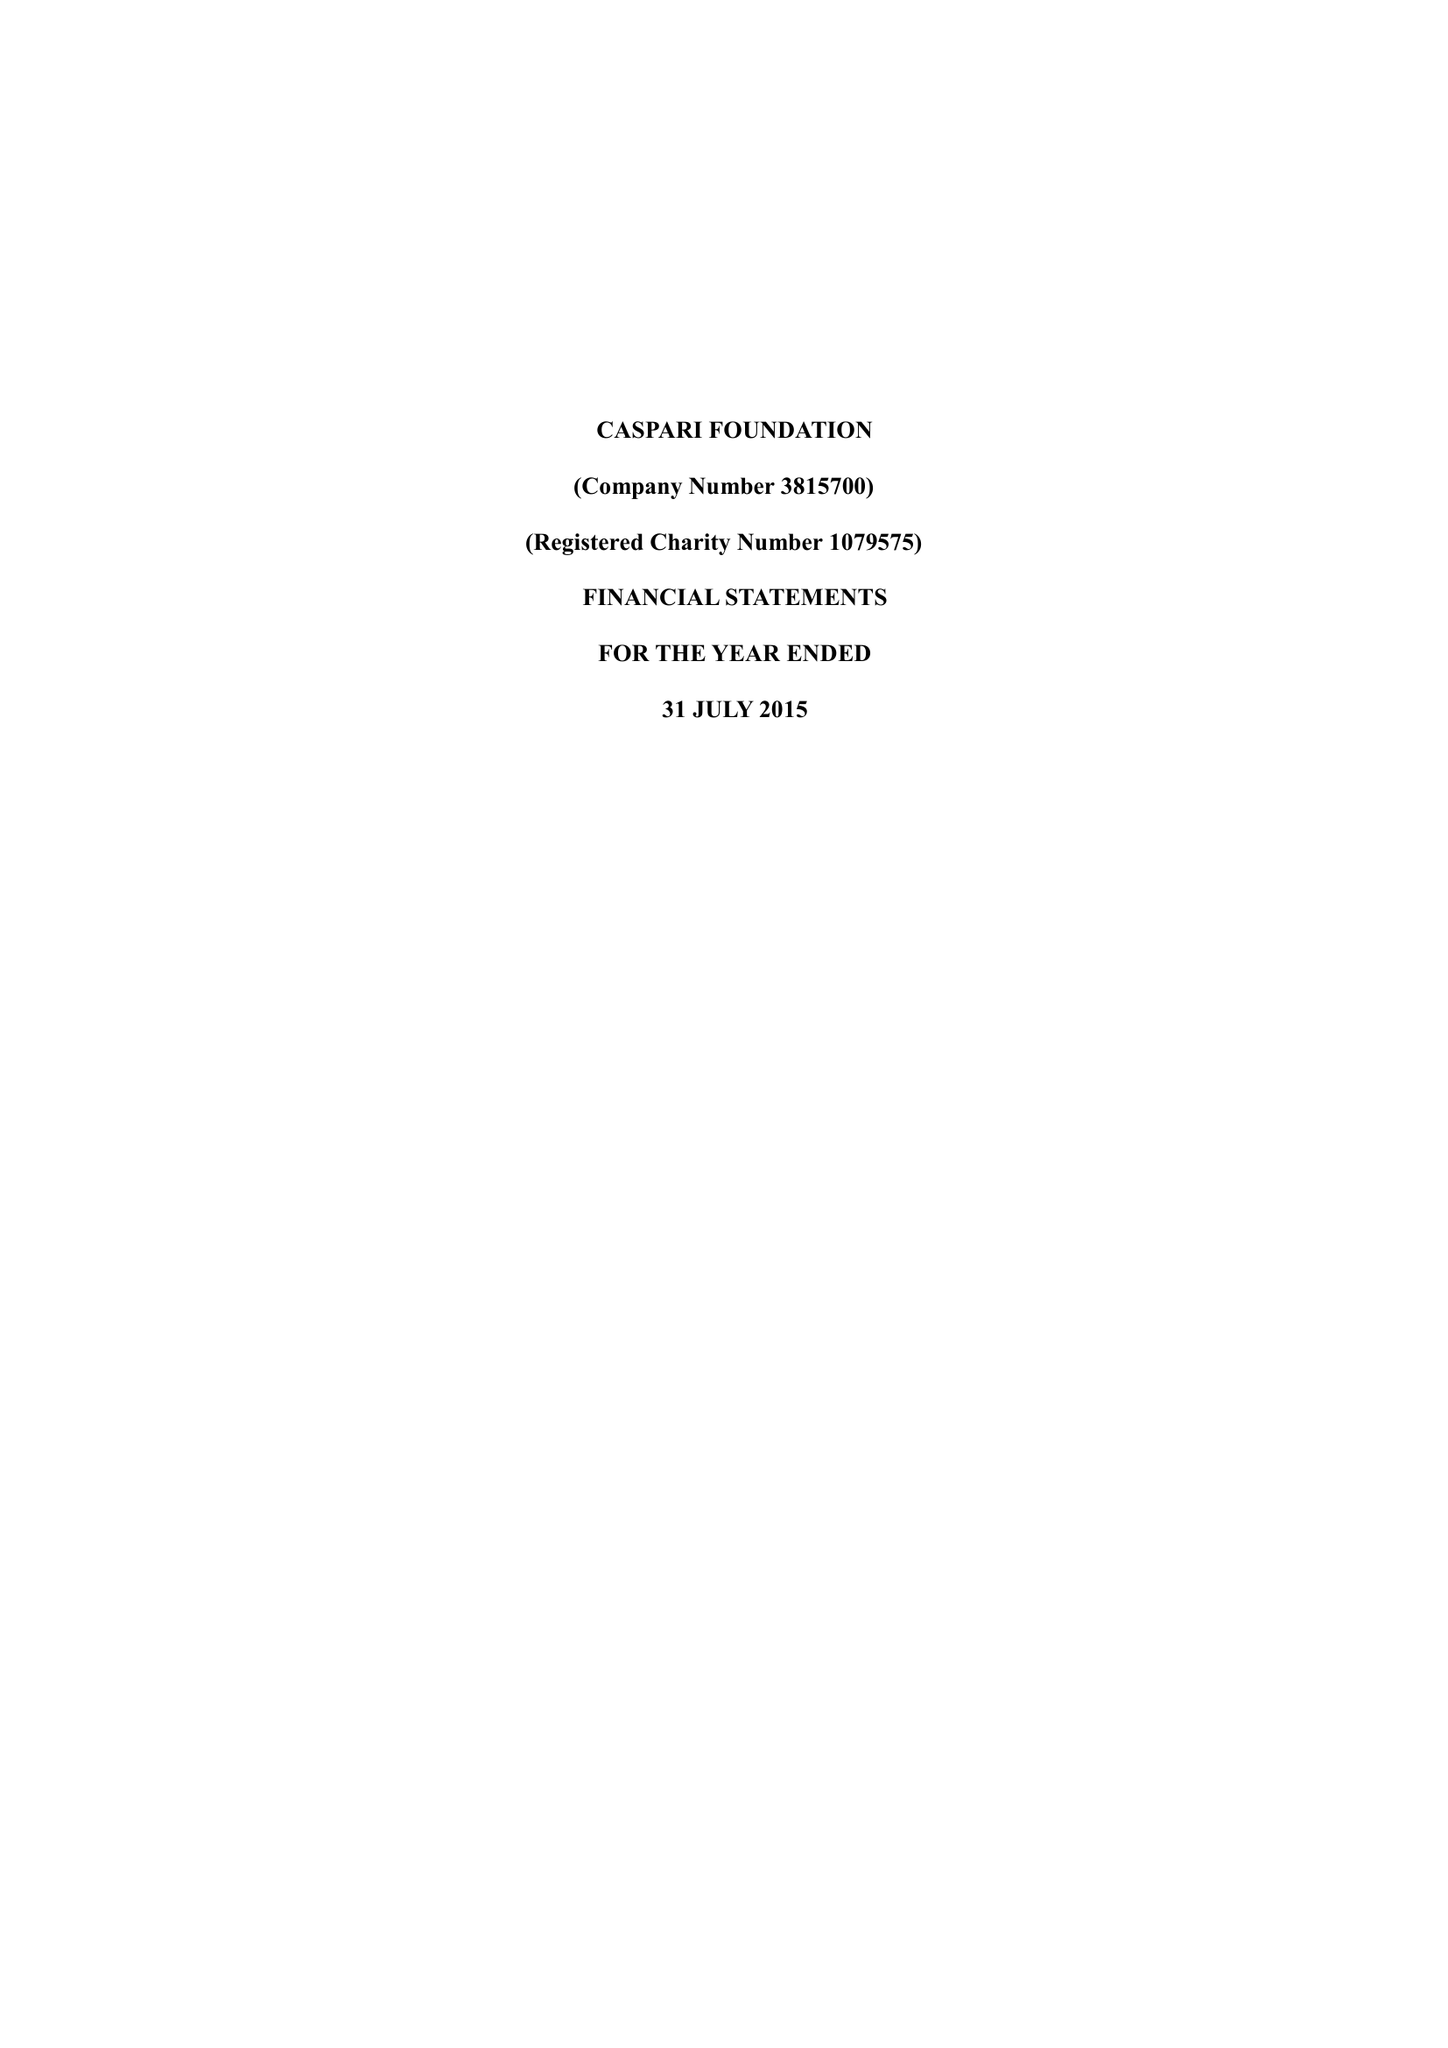What is the value for the charity_number?
Answer the question using a single word or phrase. 1079575 